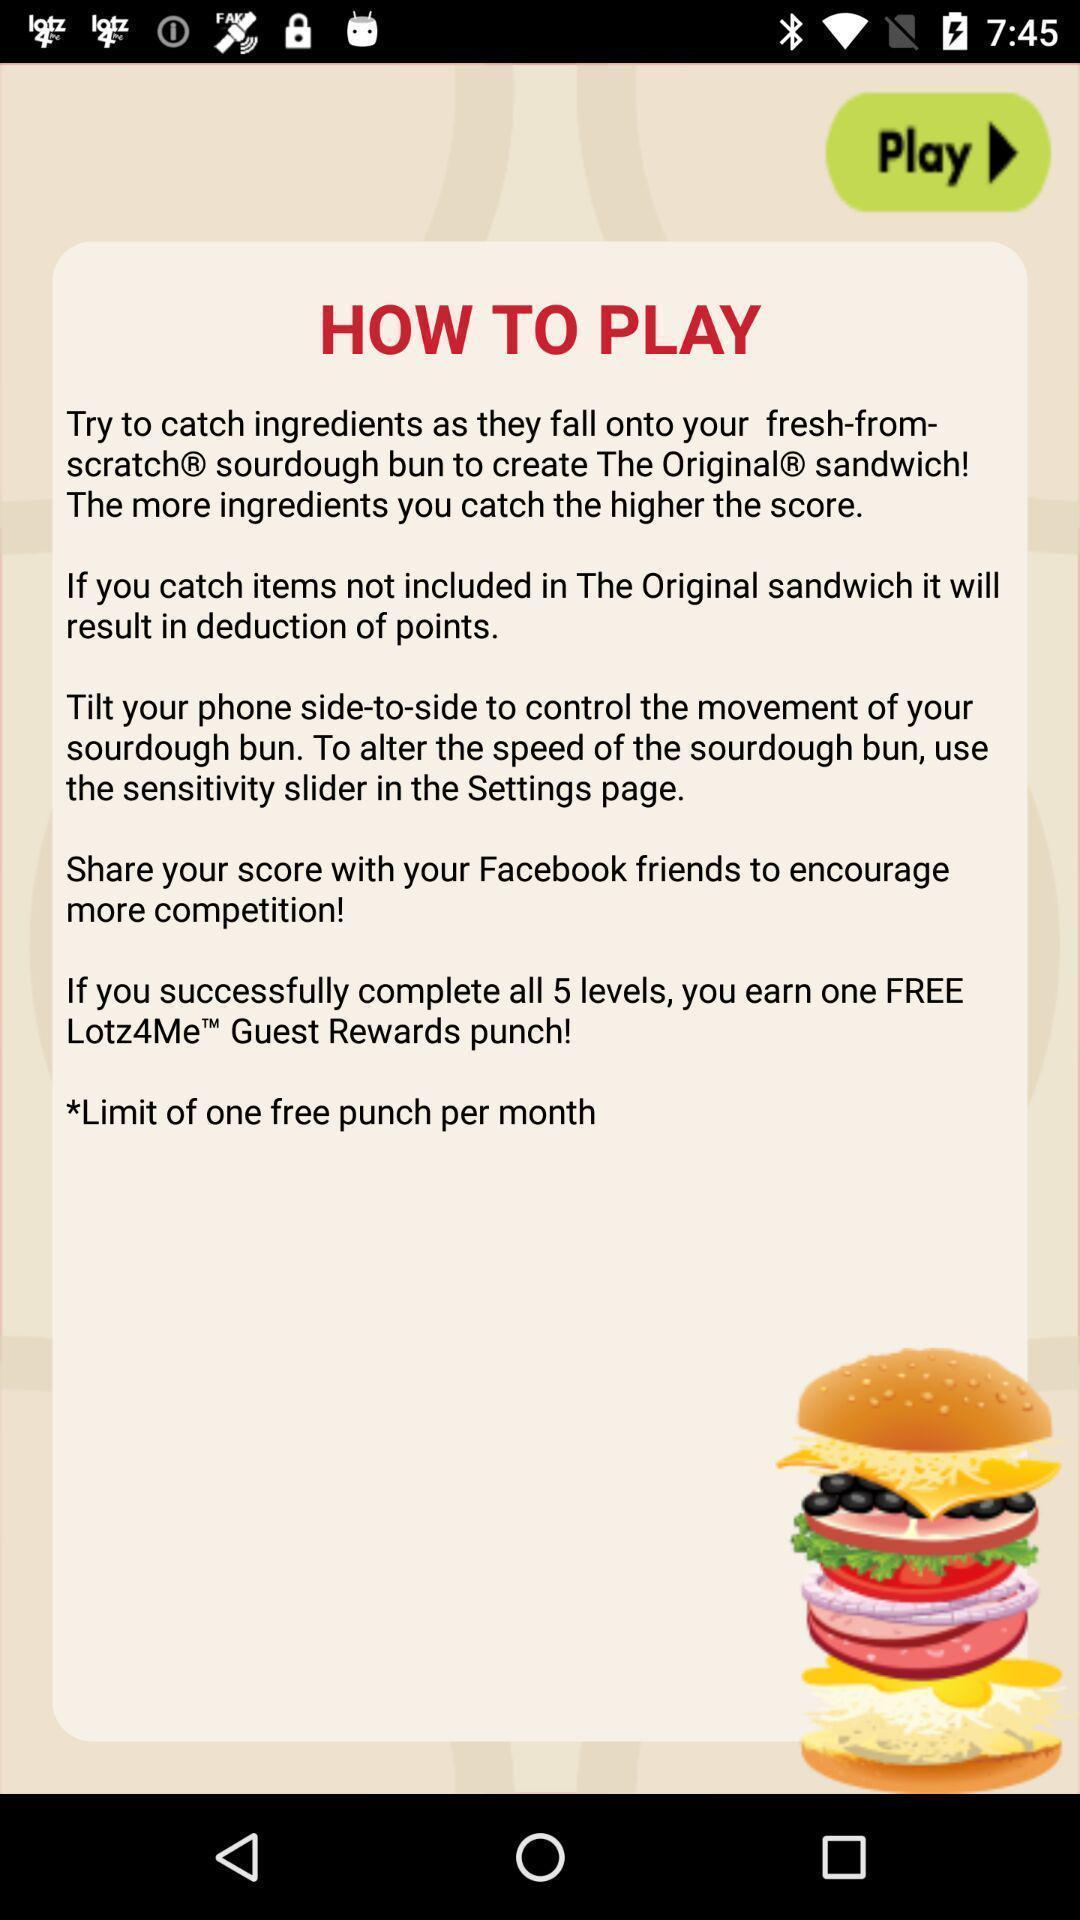Summarize the information in this screenshot. Screen display information about how to play. 